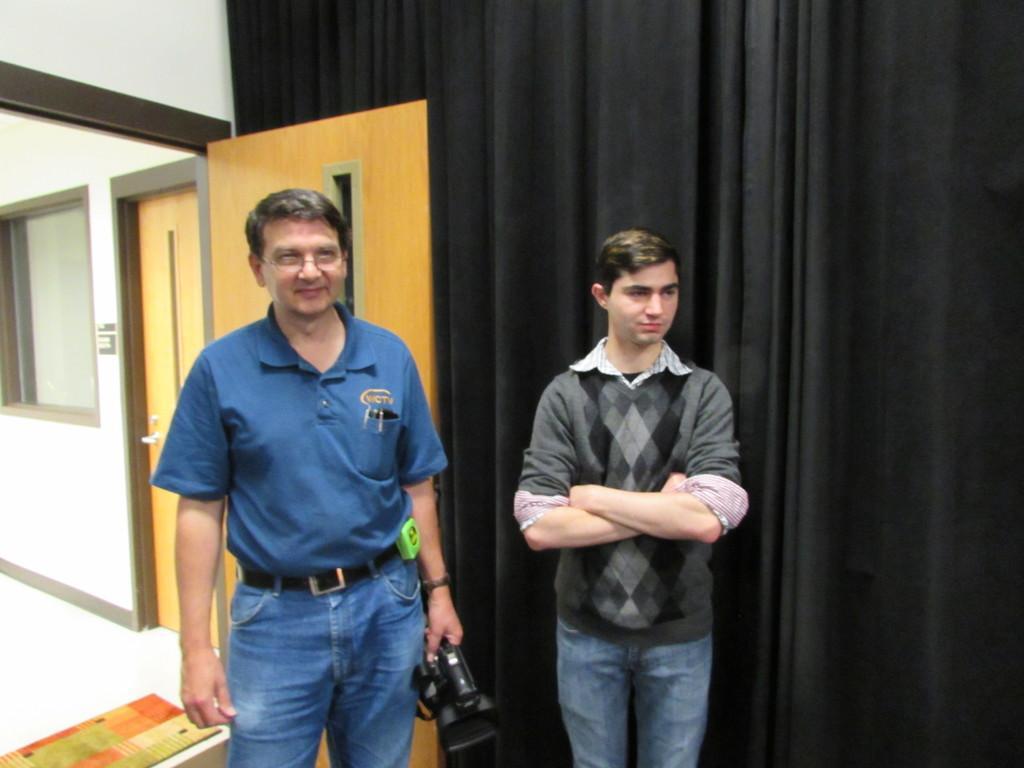How would you summarize this image in a sentence or two? In this picture there are two men standing, among them one man holding a camera. We can see curtains, door and mat on the floor. In the background of the image we can see wall, door and window. 